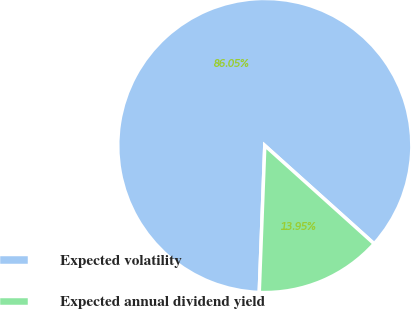Convert chart to OTSL. <chart><loc_0><loc_0><loc_500><loc_500><pie_chart><fcel>Expected volatility<fcel>Expected annual dividend yield<nl><fcel>86.05%<fcel>13.95%<nl></chart> 